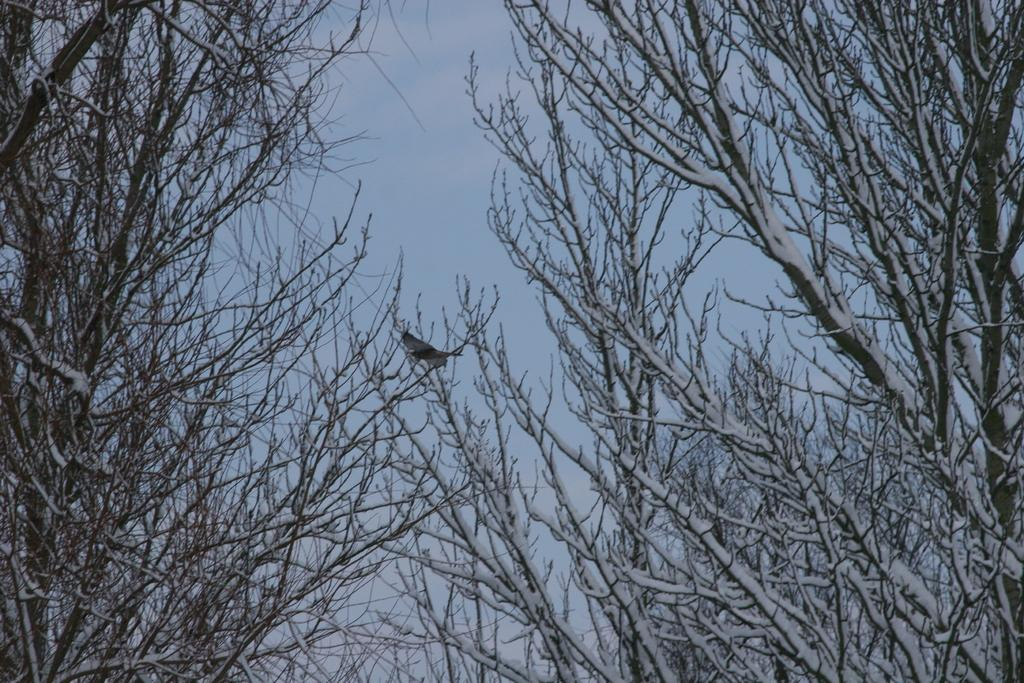What can be seen in the middle of the picture? There are trees in the middle of the picture. Are there any animals visible in the image? Yes, there is a bird on the branch of a tree in the middle of the picture. What is visible in the background of the picture? The sky is visible in the background of the picture. How many men are herding the sheep in the image? There are no men or sheep present in the image; it features trees and a bird. What type of war is depicted in the image? There is no war depicted in the image; it features trees, a bird, and the sky. 